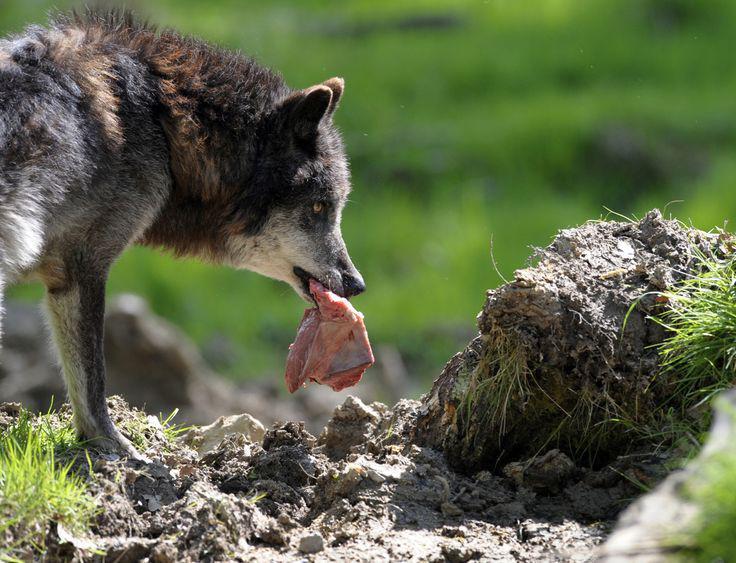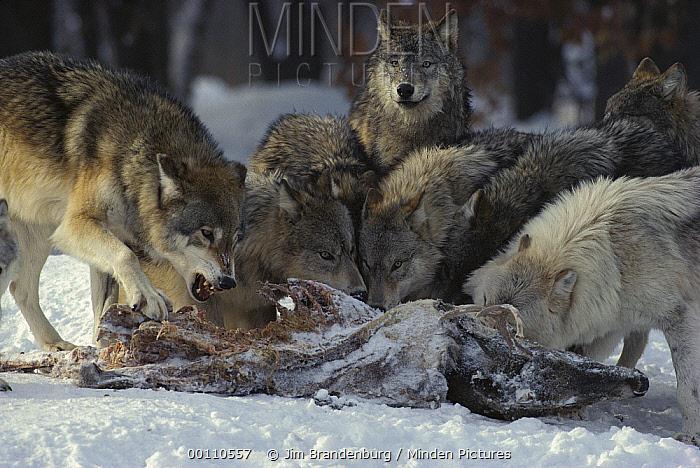The first image is the image on the left, the second image is the image on the right. Assess this claim about the two images: "In the image on the left, a wolf bares its teeth, while looking towards the camera person.". Correct or not? Answer yes or no. No. The first image is the image on the left, the second image is the image on the right. For the images shown, is this caption "There is no more than one wolf in the right image." true? Answer yes or no. No. 